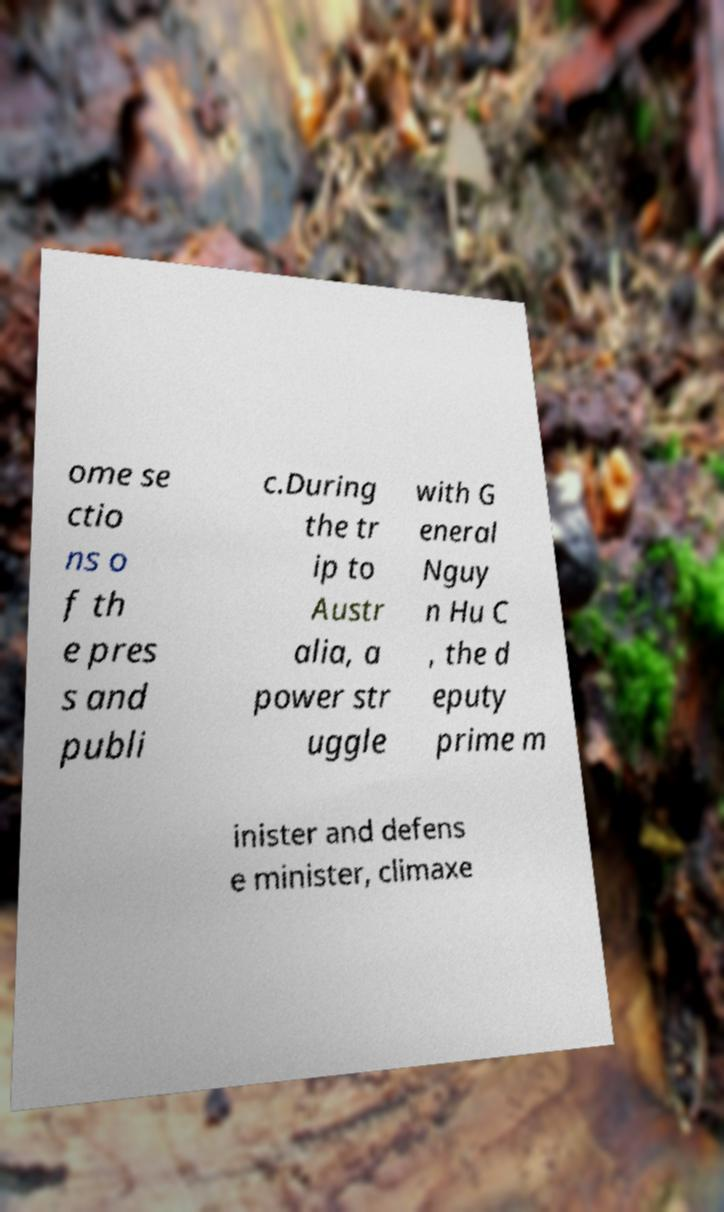Please read and relay the text visible in this image. What does it say? ome se ctio ns o f th e pres s and publi c.During the tr ip to Austr alia, a power str uggle with G eneral Nguy n Hu C , the d eputy prime m inister and defens e minister, climaxe 